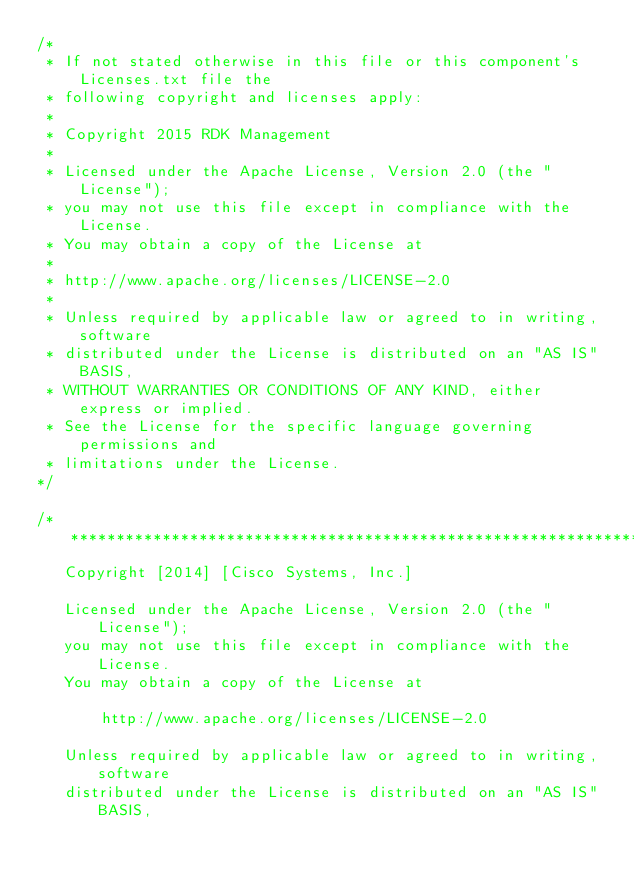<code> <loc_0><loc_0><loc_500><loc_500><_C_>/*
 * If not stated otherwise in this file or this component's Licenses.txt file the
 * following copyright and licenses apply:
 *
 * Copyright 2015 RDK Management
 *
 * Licensed under the Apache License, Version 2.0 (the "License");
 * you may not use this file except in compliance with the License.
 * You may obtain a copy of the License at
 *
 * http://www.apache.org/licenses/LICENSE-2.0
 *
 * Unless required by applicable law or agreed to in writing, software
 * distributed under the License is distributed on an "AS IS" BASIS,
 * WITHOUT WARRANTIES OR CONDITIONS OF ANY KIND, either express or implied.
 * See the License for the specific language governing permissions and
 * limitations under the License.
*/

/**********************************************************************
   Copyright [2014] [Cisco Systems, Inc.]
 
   Licensed under the Apache License, Version 2.0 (the "License");
   you may not use this file except in compliance with the License.
   You may obtain a copy of the License at
 
       http://www.apache.org/licenses/LICENSE-2.0
 
   Unless required by applicable law or agreed to in writing, software
   distributed under the License is distributed on an "AS IS" BASIS,</code> 